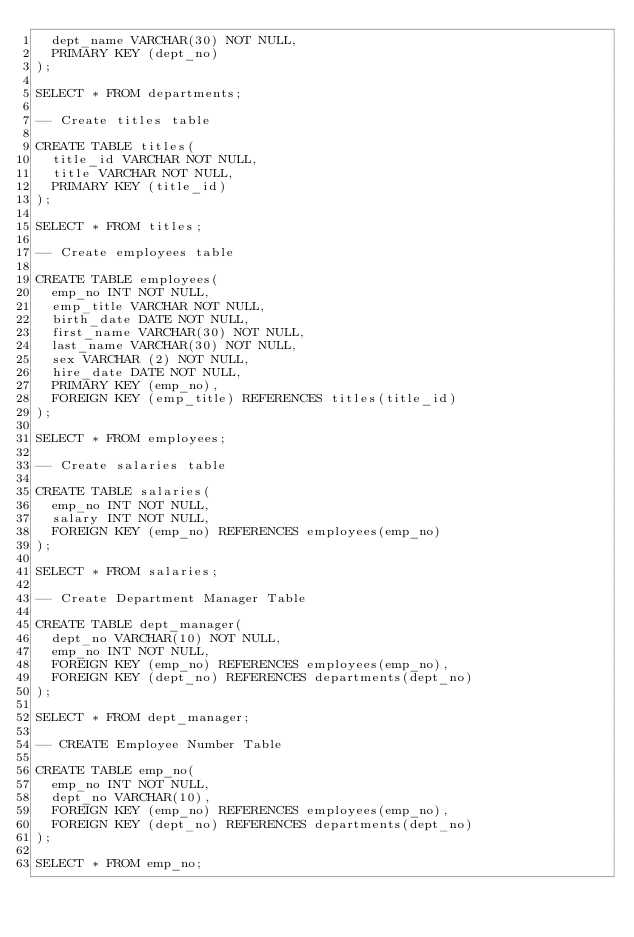Convert code to text. <code><loc_0><loc_0><loc_500><loc_500><_SQL_>	dept_name VARCHAR(30) NOT NULL,
	PRIMARY KEY (dept_no)
);

SELECT * FROM departments;

-- Create titles table

CREATE TABLE titles(
	title_id VARCHAR NOT NULL,
	title VARCHAR NOT NULL,
	PRIMARY KEY (title_id)
);

SELECT * FROM titles;

-- Create employees table

CREATE TABLE employees(
	emp_no INT NOT NULL,
	emp_title VARCHAR NOT NULL,
	birth_date DATE NOT NULL,
	first_name VARCHAR(30) NOT NULL,
	last_name VARCHAR(30) NOT NULL,
	sex VARCHAR (2) NOT NULL,
	hire_date DATE NOT NULL,
	PRIMARY KEY (emp_no),
	FOREIGN KEY (emp_title) REFERENCES titles(title_id)
);

SELECT * FROM employees;

-- Create salaries table

CREATE TABLE salaries(
	emp_no INT NOT NULL,
	salary INT NOT NULL,
	FOREIGN KEY (emp_no) REFERENCES employees(emp_no)
);

SELECT * FROM salaries;

-- Create Department Manager Table

CREATE TABLE dept_manager(
	dept_no VARCHAR(10) NOT NULL,
	emp_no INT NOT NULL,
	FOREIGN KEY (emp_no) REFERENCES employees(emp_no),
	FOREIGN KEY (dept_no) REFERENCES departments(dept_no)
);

SELECT * FROM dept_manager;

-- CREATE Employee Number Table

CREATE TABLE emp_no(
	emp_no INT NOT NULL,
	dept_no VARCHAR(10),
	FOREIGN KEY (emp_no) REFERENCES employees(emp_no),
	FOREIGN KEY (dept_no) REFERENCES departments(dept_no)
);

SELECT * FROM emp_no;












</code> 